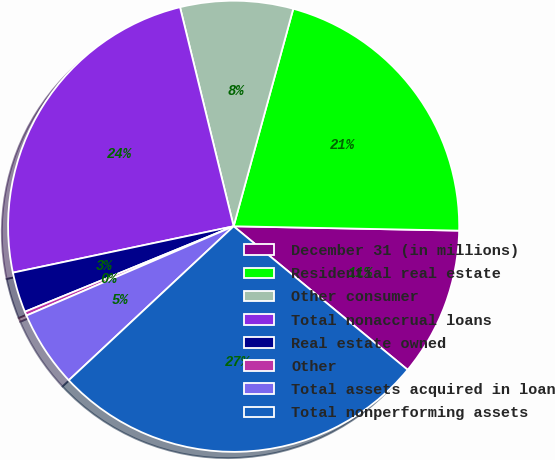Convert chart to OTSL. <chart><loc_0><loc_0><loc_500><loc_500><pie_chart><fcel>December 31 (in millions)<fcel>Residential real estate<fcel>Other consumer<fcel>Total nonaccrual loans<fcel>Real estate owned<fcel>Other<fcel>Total assets acquired in loan<fcel>Total nonperforming assets<nl><fcel>10.67%<fcel>21.05%<fcel>8.08%<fcel>24.48%<fcel>2.89%<fcel>0.29%<fcel>5.48%<fcel>27.07%<nl></chart> 